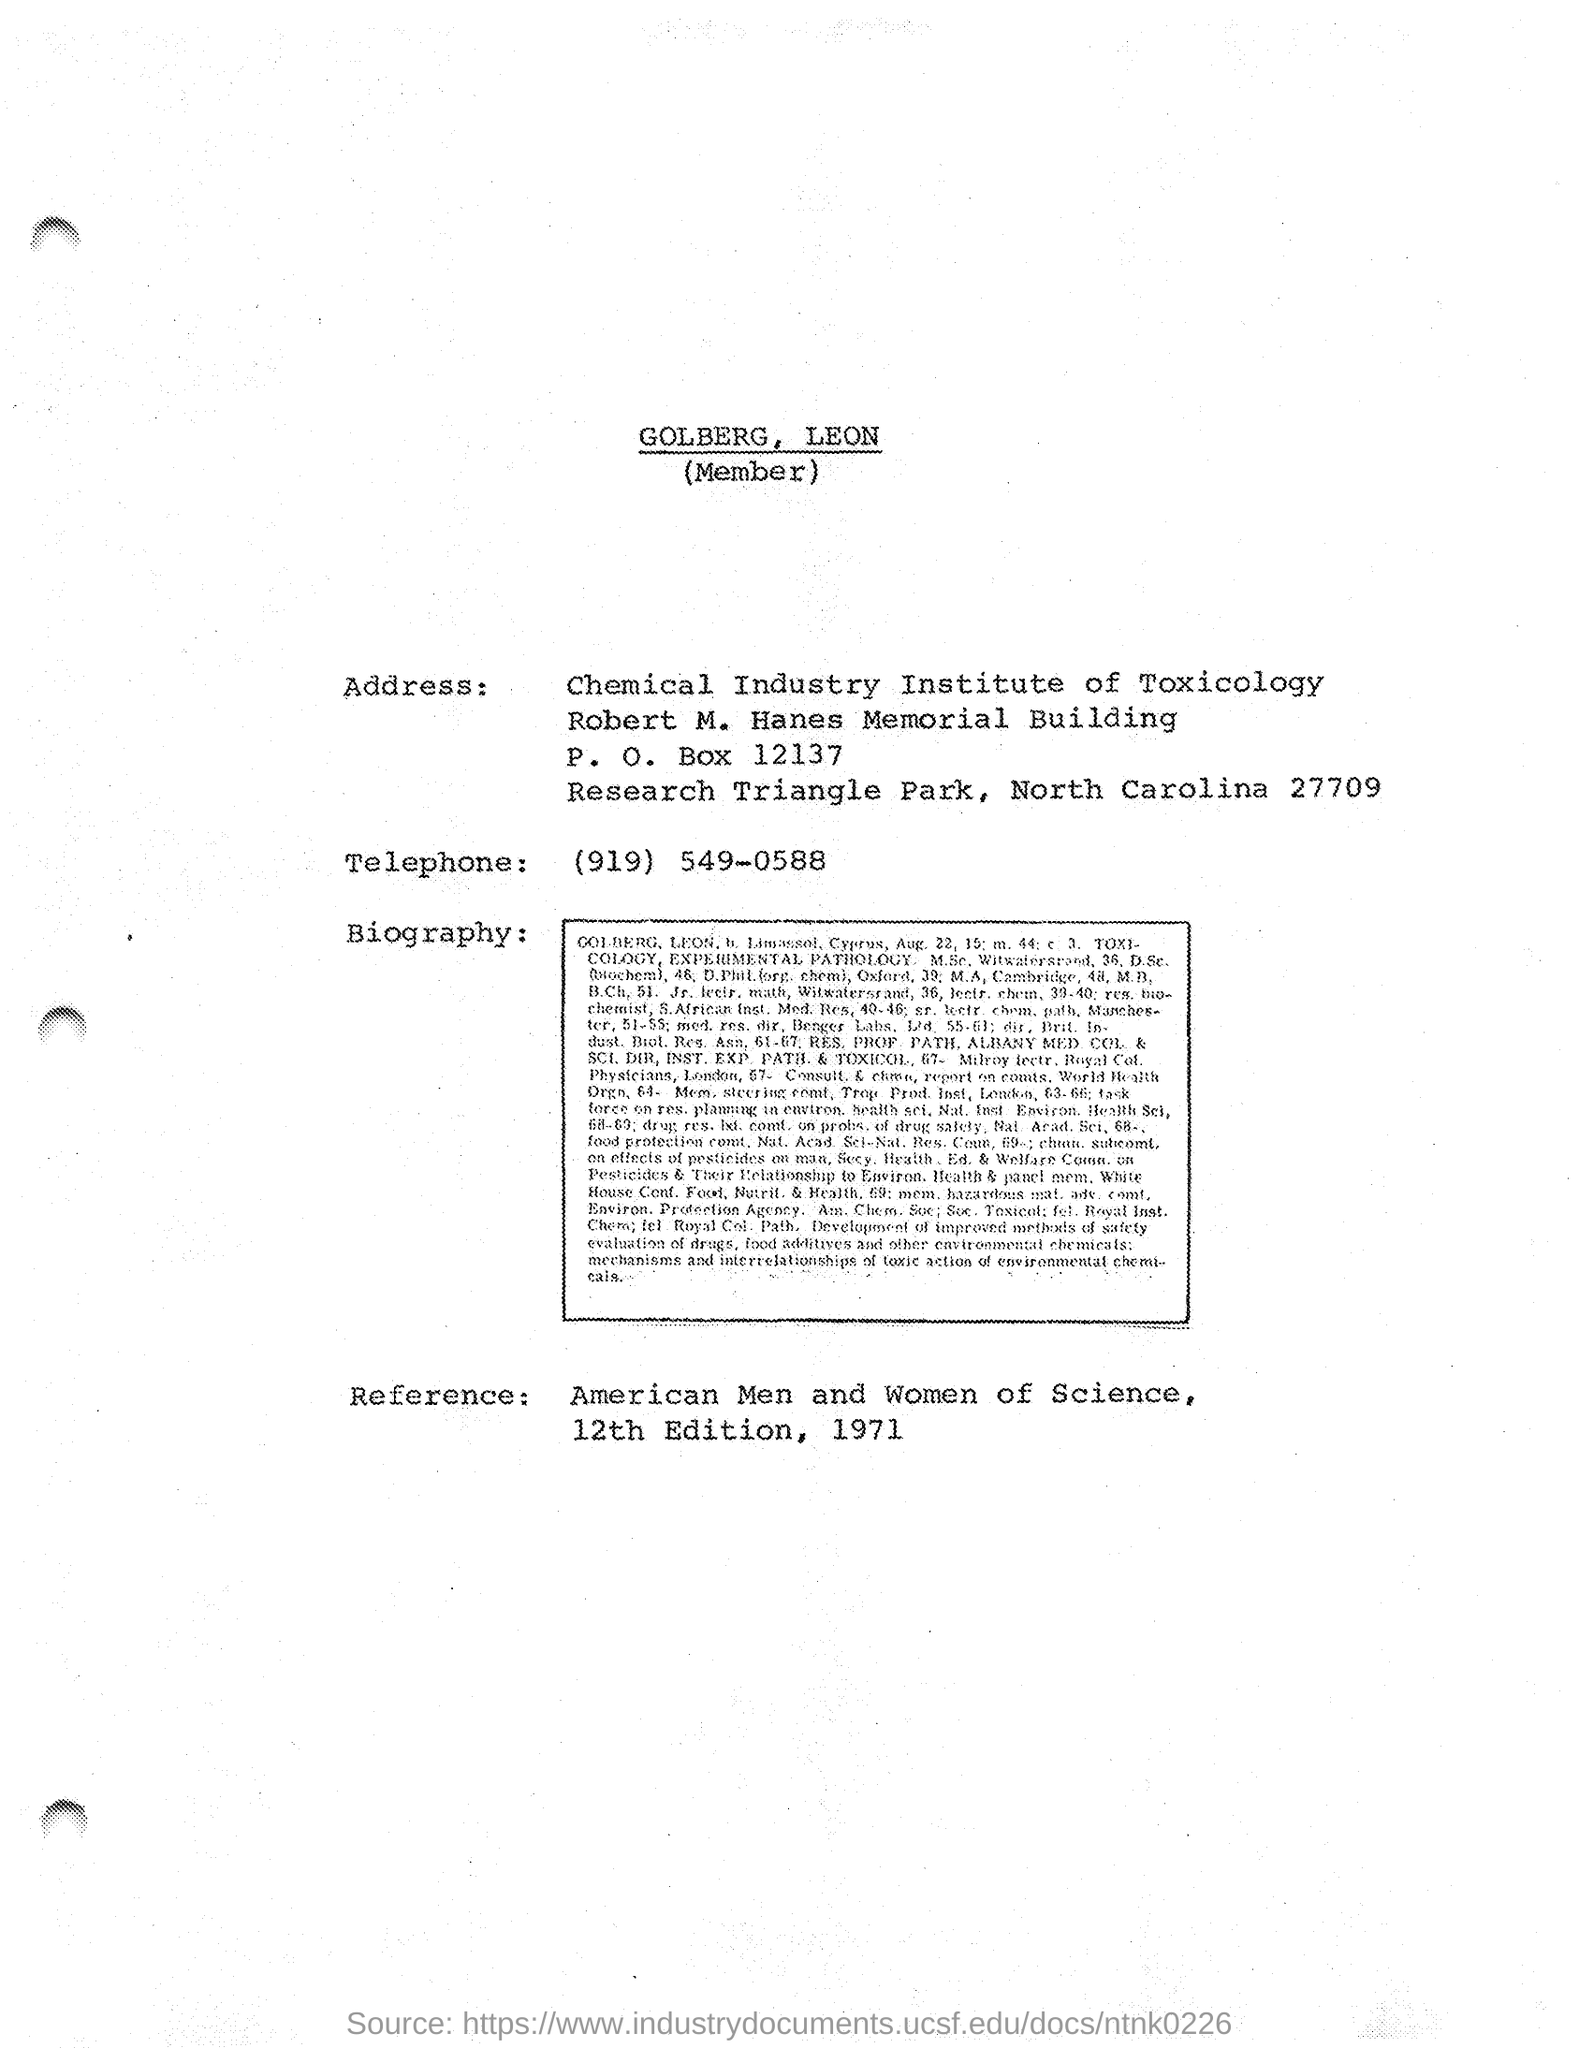Identify some key points in this picture. The Chemical Industry Institute of Toxicology is located in North Carolina. 